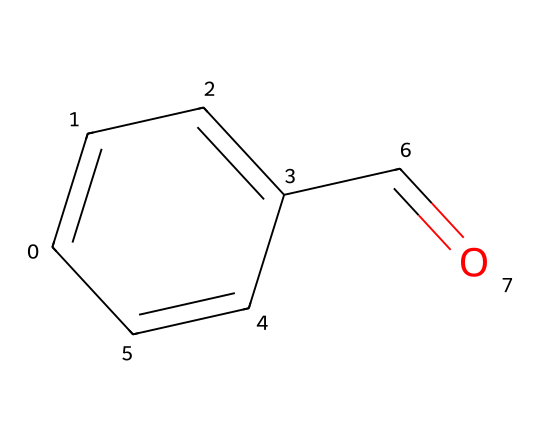What is the common name for this chemical? The SMILES notation denotes the structure of benzaldehyde, which is recognized as the primary component in artificial almond flavor.
Answer: benzaldehyde How many carbon atoms are in this molecule? By analyzing the structure represented in the SMILES, we observe that there are six carbon atoms present in the compound (C=C=C represents three carbons and the aldehyde contributes one additional carbon).
Answer: six What functional group is present in this chemical? The presence of the carbonyl group (C=O) at the end of the carbon chain indicates that the compound belongs to the aldehyde family, defining its functional group.
Answer: aldehyde How many hydrogen atoms are in benzaldehyde? Each carbon typically forms four bonds; considering the bonding requirements for the carbon atoms in the structure and the presence of the aldehyde, there are four hydrogen atoms overall in benzaldehyde.
Answer: four What property of benzaldehyde contributes to its almond flavor? The molecular structure of benzaldehyde includes a unique arrangement of aromatic and carbonyl groups that contribute to the sweet and nutty attributes characteristic of almond flavor, linking directly to its chemical nature.
Answer: aromatic structure Is benzaldehyde considered a safe flavoring agent? Benzaldehyde is generally recognized as safe for consumption in limited quantities; however, exposure to higher concentrations can cause irritation, requiring careful regulation in food applications.
Answer: yes 